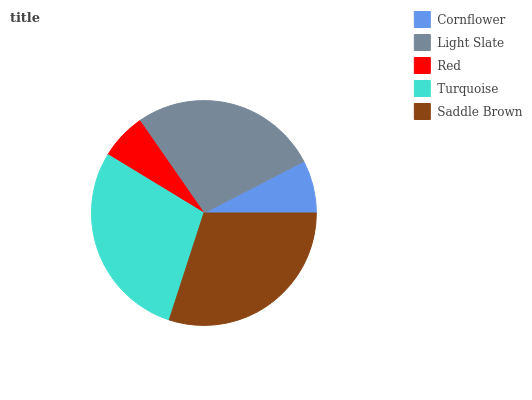Is Red the minimum?
Answer yes or no. Yes. Is Saddle Brown the maximum?
Answer yes or no. Yes. Is Light Slate the minimum?
Answer yes or no. No. Is Light Slate the maximum?
Answer yes or no. No. Is Light Slate greater than Cornflower?
Answer yes or no. Yes. Is Cornflower less than Light Slate?
Answer yes or no. Yes. Is Cornflower greater than Light Slate?
Answer yes or no. No. Is Light Slate less than Cornflower?
Answer yes or no. No. Is Light Slate the high median?
Answer yes or no. Yes. Is Light Slate the low median?
Answer yes or no. Yes. Is Saddle Brown the high median?
Answer yes or no. No. Is Red the low median?
Answer yes or no. No. 